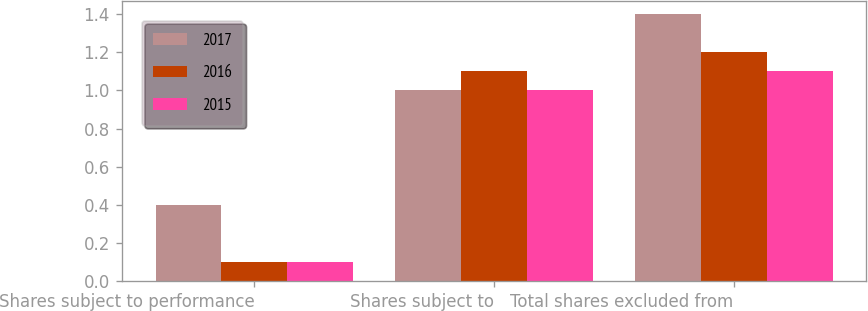Convert chart to OTSL. <chart><loc_0><loc_0><loc_500><loc_500><stacked_bar_chart><ecel><fcel>Shares subject to performance<fcel>Shares subject to<fcel>Total shares excluded from<nl><fcel>2017<fcel>0.4<fcel>1<fcel>1.4<nl><fcel>2016<fcel>0.1<fcel>1.1<fcel>1.2<nl><fcel>2015<fcel>0.1<fcel>1<fcel>1.1<nl></chart> 